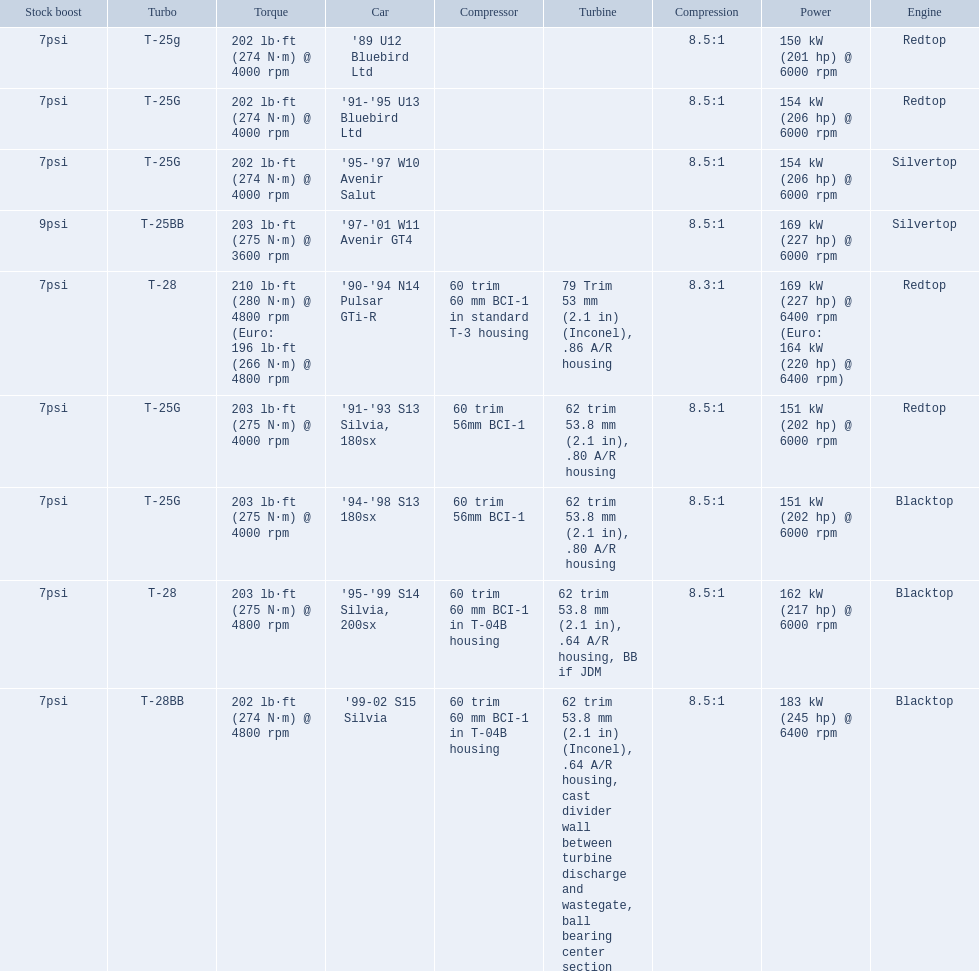What are the listed hp of the cars? 150 kW (201 hp) @ 6000 rpm, 154 kW (206 hp) @ 6000 rpm, 154 kW (206 hp) @ 6000 rpm, 169 kW (227 hp) @ 6000 rpm, 169 kW (227 hp) @ 6400 rpm (Euro: 164 kW (220 hp) @ 6400 rpm), 151 kW (202 hp) @ 6000 rpm, 151 kW (202 hp) @ 6000 rpm, 162 kW (217 hp) @ 6000 rpm, 183 kW (245 hp) @ 6400 rpm. Which is the only car with over 230 hp? '99-02 S15 Silvia. 